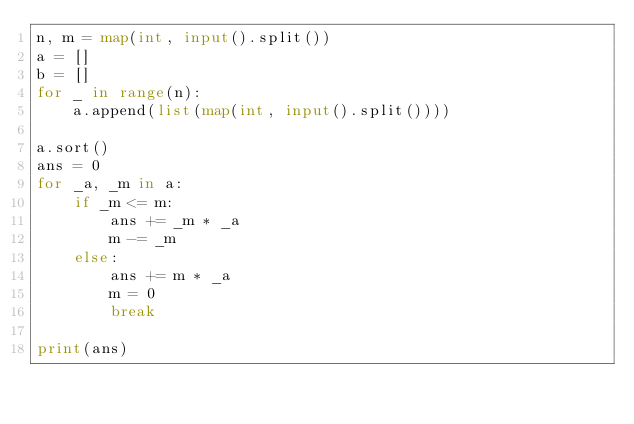Convert code to text. <code><loc_0><loc_0><loc_500><loc_500><_Python_>n, m = map(int, input().split())
a = []
b = []
for _ in range(n):
    a.append(list(map(int, input().split())))

a.sort()
ans = 0
for _a, _m in a:
    if _m <= m:
        ans += _m * _a
        m -= _m
    else:
        ans += m * _a
        m = 0
        break

print(ans)
</code> 